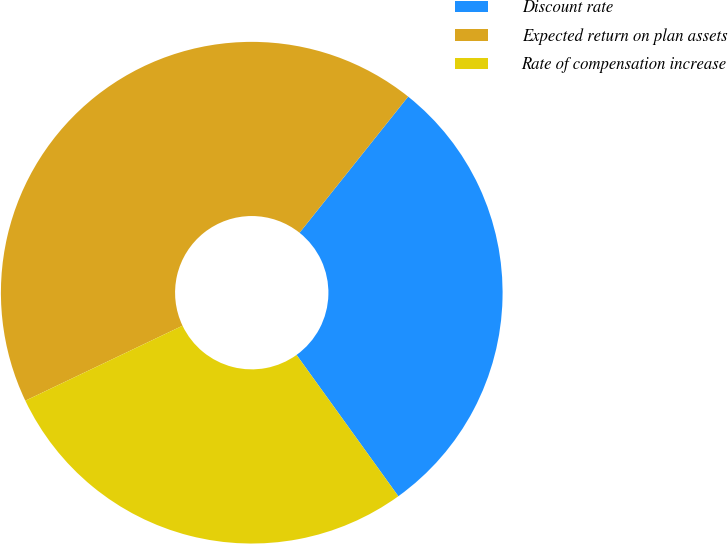Convert chart to OTSL. <chart><loc_0><loc_0><loc_500><loc_500><pie_chart><fcel>Discount rate<fcel>Expected return on plan assets<fcel>Rate of compensation increase<nl><fcel>29.35%<fcel>42.8%<fcel>27.85%<nl></chart> 